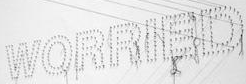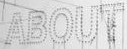What words are shown in these images in order, separated by a semicolon? WORRIED; ABOUT 